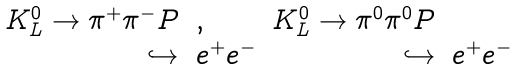<formula> <loc_0><loc_0><loc_500><loc_500>\begin{array} { r l r l } { { K _ { L } ^ { 0 } \to \pi ^ { + } \pi ^ { - } P } } & { , } & { { K _ { L } ^ { 0 } \to \pi ^ { 0 } \pi ^ { 0 } P } } \\ { \hookrightarrow } & { { e ^ { + } e ^ { - } } } & { \hookrightarrow } & { { e ^ { + } e ^ { - } } } \end{array}</formula> 